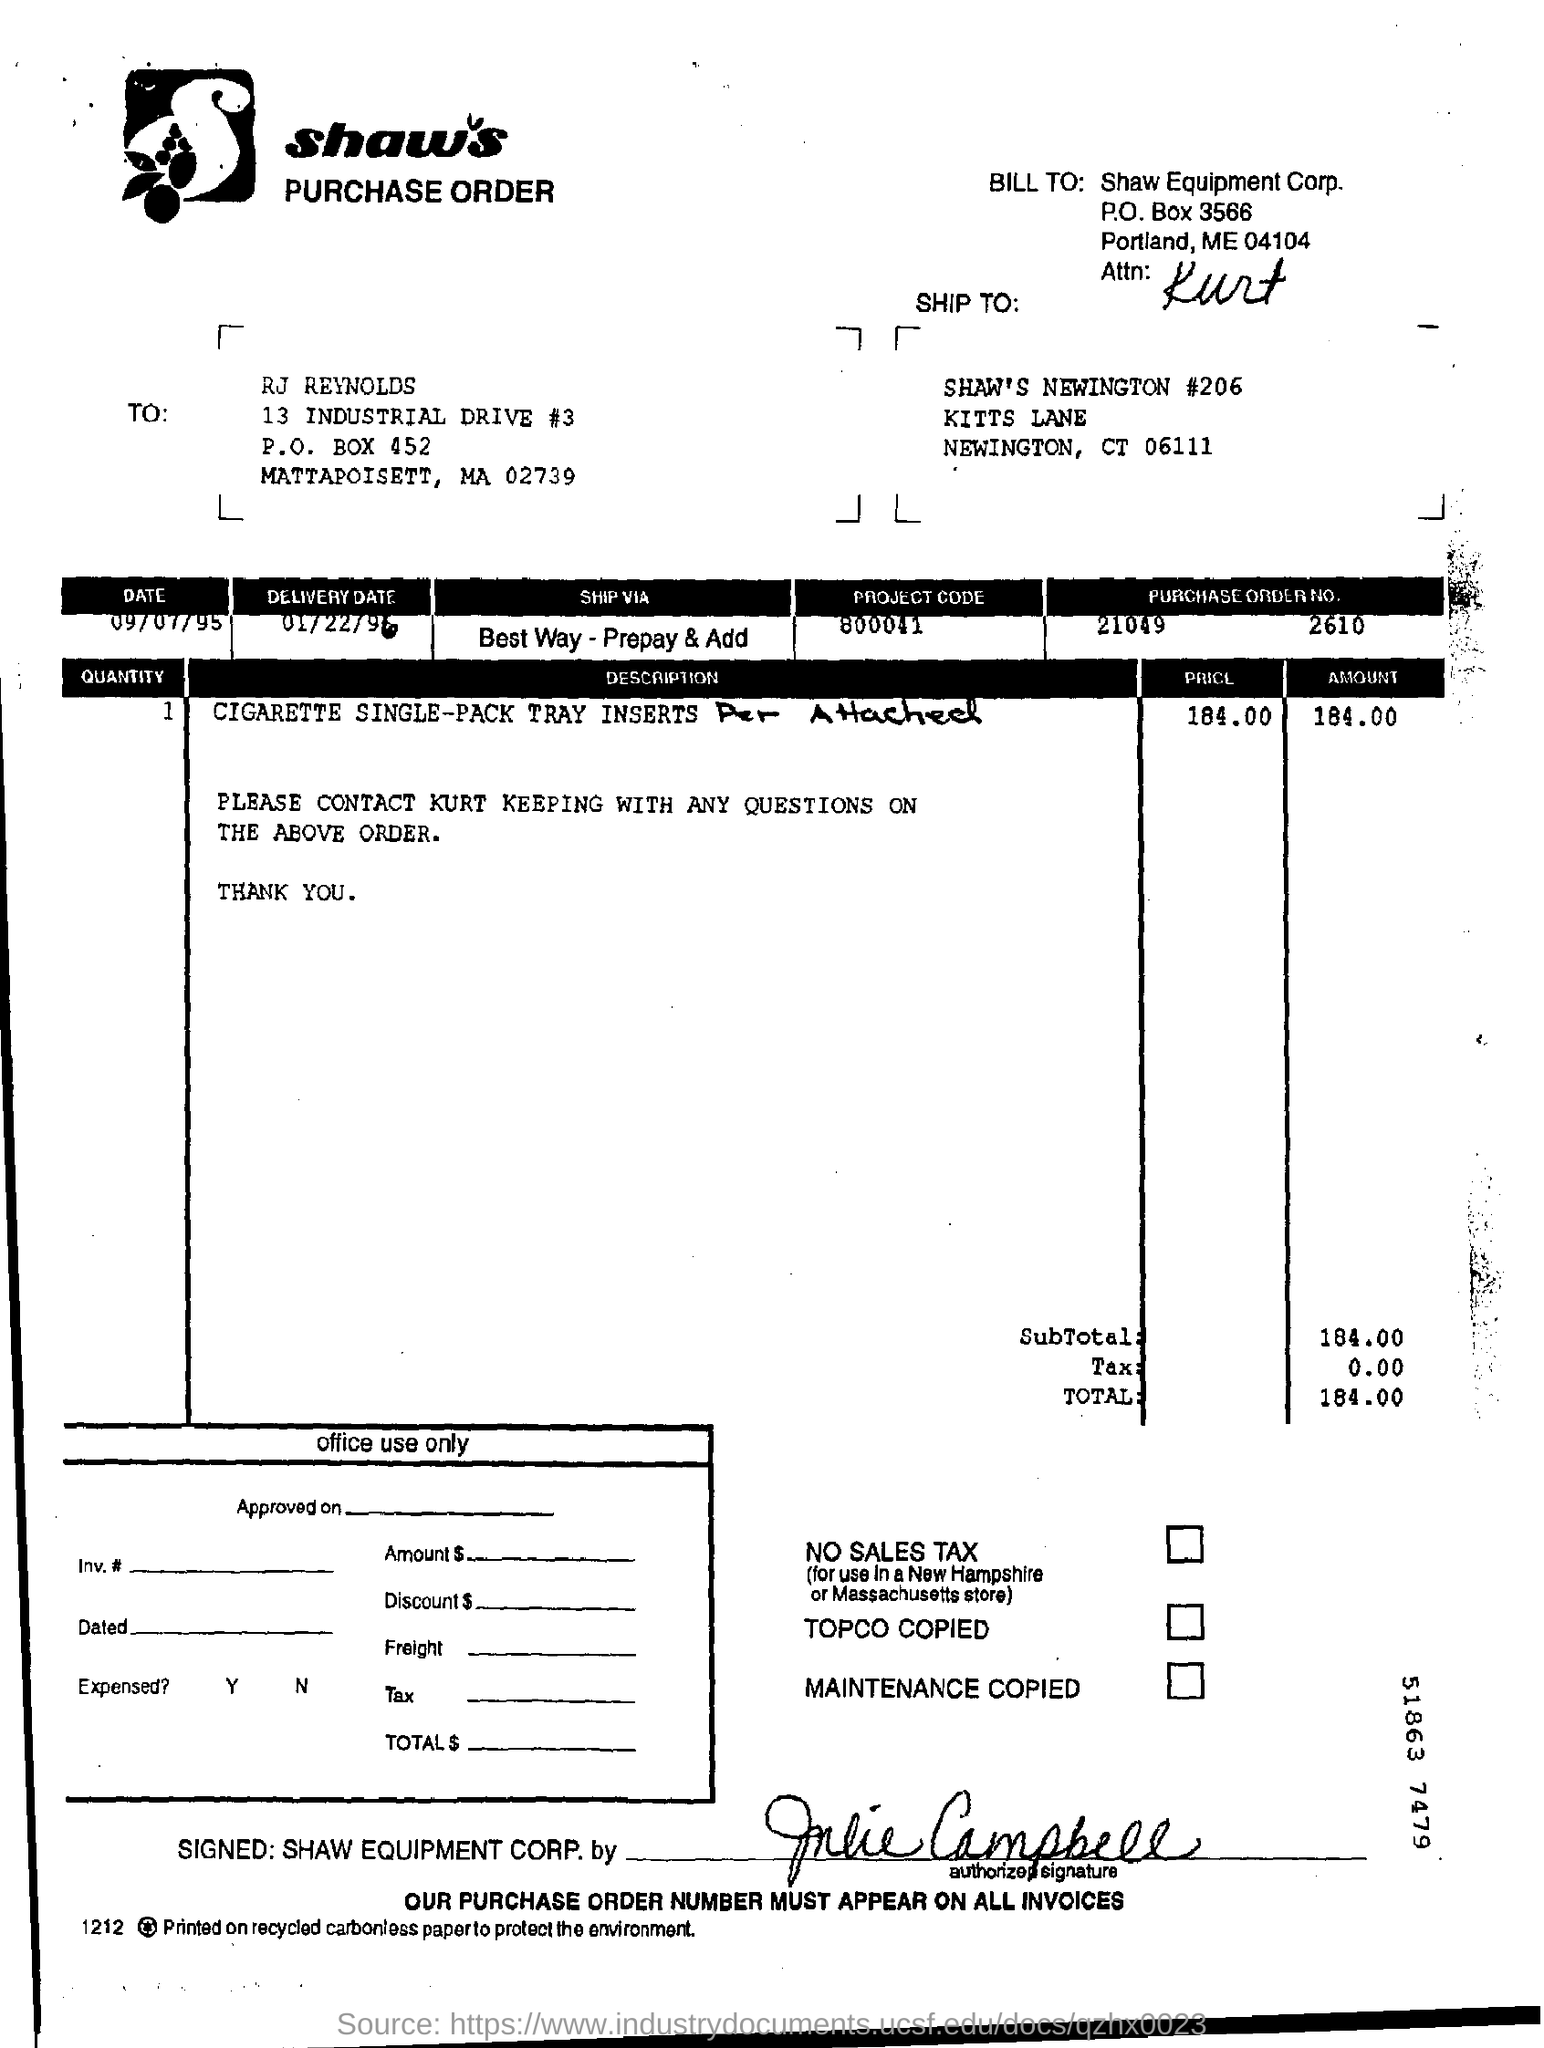What is the project code ?
Offer a very short reply. 800041. What is the delivery date ?
Give a very brief answer. 01/22/96. What is the purchase order no ?
Give a very brief answer. 21049       2610. 